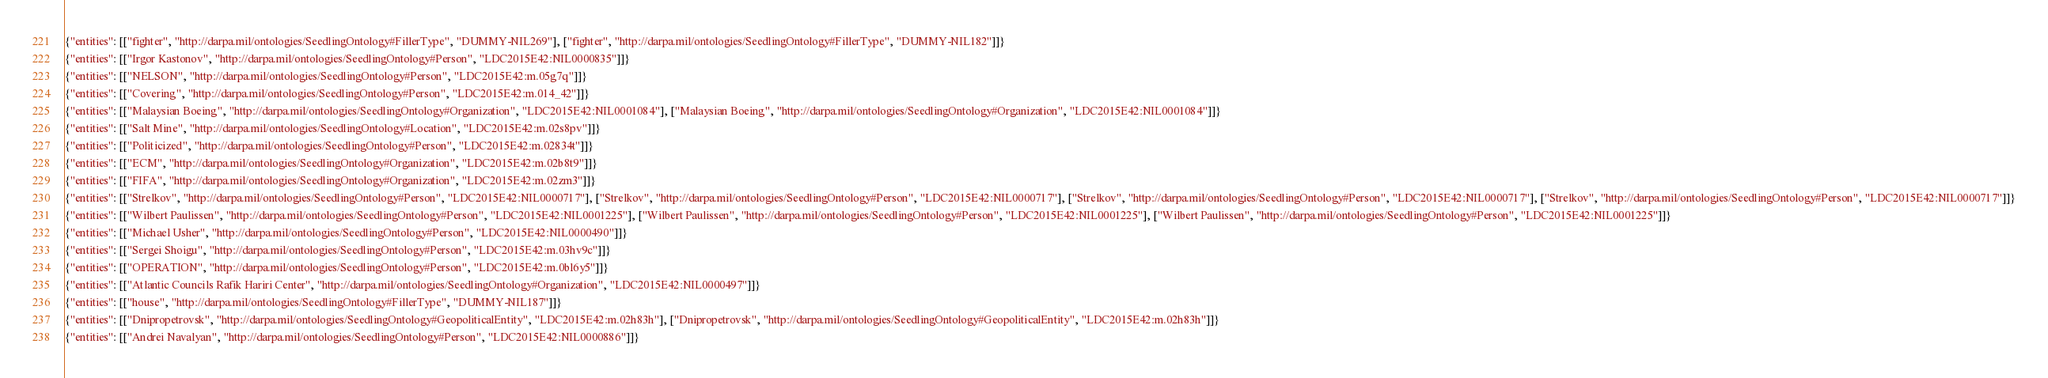Convert code to text. <code><loc_0><loc_0><loc_500><loc_500><_Julia_>{"entities": [["fighter", "http://darpa.mil/ontologies/SeedlingOntology#FillerType", "DUMMY-NIL269"], ["fighter", "http://darpa.mil/ontologies/SeedlingOntology#FillerType", "DUMMY-NIL182"]]}
{"entities": [["Irgor Kastonov", "http://darpa.mil/ontologies/SeedlingOntology#Person", "LDC2015E42:NIL0000835"]]}
{"entities": [["NELSON", "http://darpa.mil/ontologies/SeedlingOntology#Person", "LDC2015E42:m.05g7q"]]}
{"entities": [["Covering", "http://darpa.mil/ontologies/SeedlingOntology#Person", "LDC2015E42:m.014_42"]]}
{"entities": [["Malaysian Boeing", "http://darpa.mil/ontologies/SeedlingOntology#Organization", "LDC2015E42:NIL0001084"], ["Malaysian Boeing", "http://darpa.mil/ontologies/SeedlingOntology#Organization", "LDC2015E42:NIL0001084"]]}
{"entities": [["Salt Mine", "http://darpa.mil/ontologies/SeedlingOntology#Location", "LDC2015E42:m.02s8pv"]]}
{"entities": [["Politicized", "http://darpa.mil/ontologies/SeedlingOntology#Person", "LDC2015E42:m.02834t"]]}
{"entities": [["ECM", "http://darpa.mil/ontologies/SeedlingOntology#Organization", "LDC2015E42:m.02b8t9"]]}
{"entities": [["FIFA", "http://darpa.mil/ontologies/SeedlingOntology#Organization", "LDC2015E42:m.02zm3"]]}
{"entities": [["Strelkov", "http://darpa.mil/ontologies/SeedlingOntology#Person", "LDC2015E42:NIL0000717"], ["Strelkov", "http://darpa.mil/ontologies/SeedlingOntology#Person", "LDC2015E42:NIL0000717"], ["Strelkov", "http://darpa.mil/ontologies/SeedlingOntology#Person", "LDC2015E42:NIL0000717"], ["Strelkov", "http://darpa.mil/ontologies/SeedlingOntology#Person", "LDC2015E42:NIL0000717"]]}
{"entities": [["Wilbert Paulissen", "http://darpa.mil/ontologies/SeedlingOntology#Person", "LDC2015E42:NIL0001225"], ["Wilbert Paulissen", "http://darpa.mil/ontologies/SeedlingOntology#Person", "LDC2015E42:NIL0001225"], ["Wilbert Paulissen", "http://darpa.mil/ontologies/SeedlingOntology#Person", "LDC2015E42:NIL0001225"]]}
{"entities": [["Michael Usher", "http://darpa.mil/ontologies/SeedlingOntology#Person", "LDC2015E42:NIL0000490"]]}
{"entities": [["Sergei Shoigu", "http://darpa.mil/ontologies/SeedlingOntology#Person", "LDC2015E42:m.03hv9c"]]}
{"entities": [["OPERATION", "http://darpa.mil/ontologies/SeedlingOntology#Person", "LDC2015E42:m.0bl6y5"]]}
{"entities": [["Atlantic Councils Rafik Hariri Center", "http://darpa.mil/ontologies/SeedlingOntology#Organization", "LDC2015E42:NIL0000497"]]}
{"entities": [["house", "http://darpa.mil/ontologies/SeedlingOntology#FillerType", "DUMMY-NIL187"]]}
{"entities": [["Dnipropetrovsk", "http://darpa.mil/ontologies/SeedlingOntology#GeopoliticalEntity", "LDC2015E42:m.02h83h"], ["Dnipropetrovsk", "http://darpa.mil/ontologies/SeedlingOntology#GeopoliticalEntity", "LDC2015E42:m.02h83h"]]}
{"entities": [["Andrei Navalyan", "http://darpa.mil/ontologies/SeedlingOntology#Person", "LDC2015E42:NIL0000886"]]}</code> 